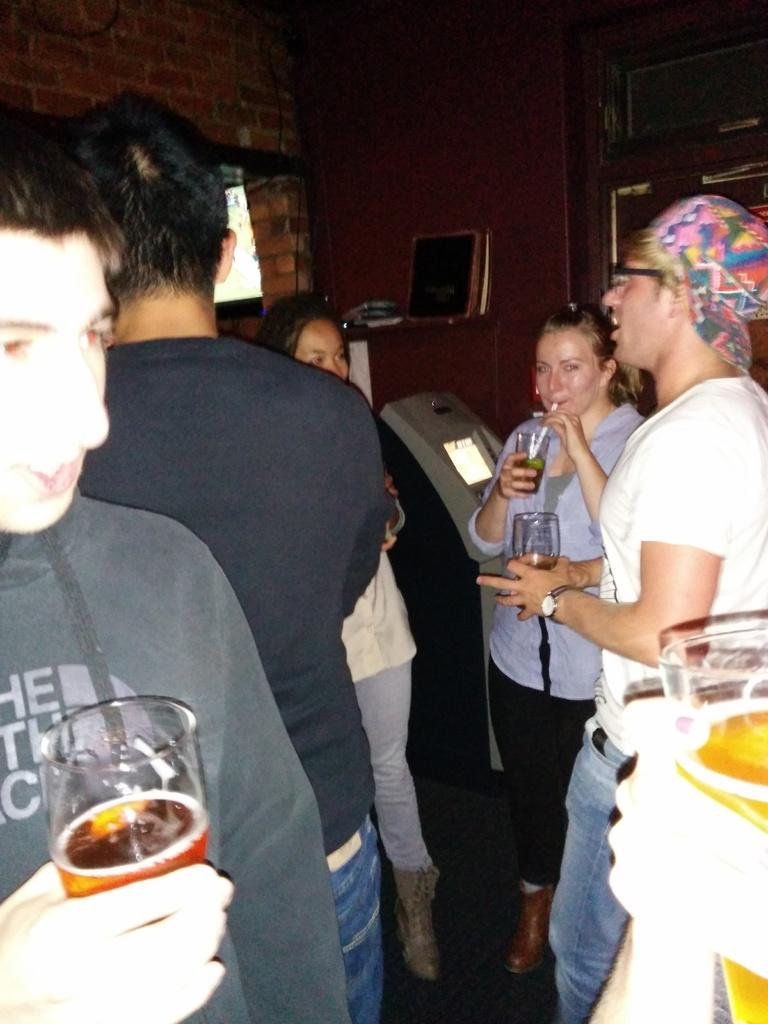What are the people in the image doing? The persons standing in the image are holding glasses. What can be seen in the background of the image? There is a wall in the background of the image. What type of flag is being waved by the person in the image? There is no flag present in the image; the persons are holding glasses. 